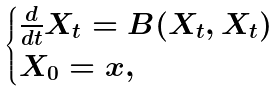<formula> <loc_0><loc_0><loc_500><loc_500>\begin{cases} \frac { d } { d t } X _ { t } = B ( X _ { t } , X _ { t } ) \\ X _ { 0 } = x , \end{cases}</formula> 